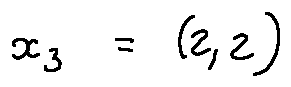<formula> <loc_0><loc_0><loc_500><loc_500>x _ { 3 } = ( 2 , 2 )</formula> 